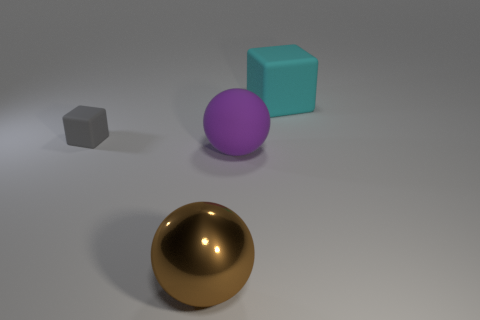Add 1 big spheres. How many objects exist? 5 Subtract 0 brown cubes. How many objects are left? 4 Subtract all big purple cubes. Subtract all metallic spheres. How many objects are left? 3 Add 1 large purple rubber things. How many large purple rubber things are left? 2 Add 2 yellow rubber cubes. How many yellow rubber cubes exist? 2 